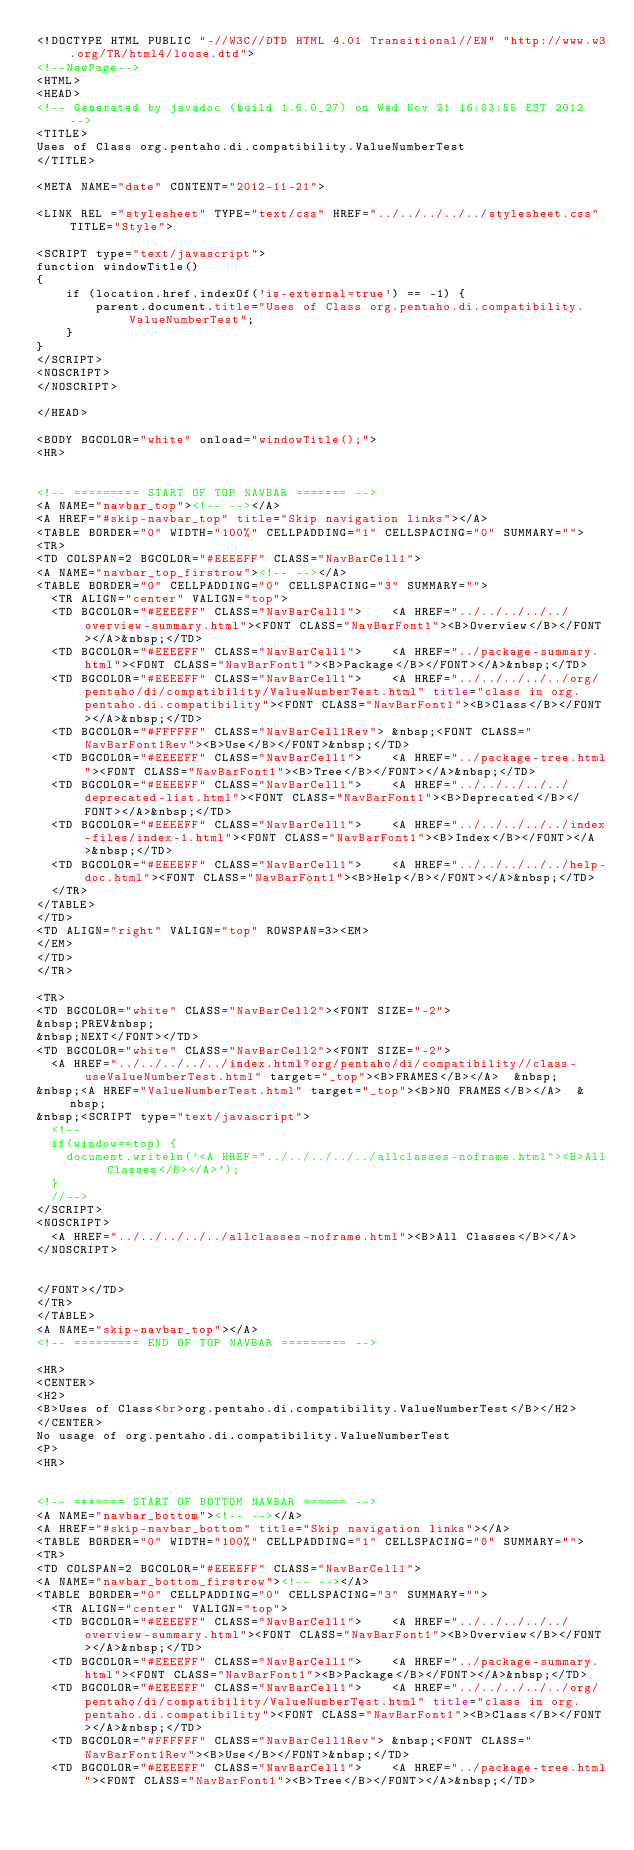Convert code to text. <code><loc_0><loc_0><loc_500><loc_500><_HTML_><!DOCTYPE HTML PUBLIC "-//W3C//DTD HTML 4.01 Transitional//EN" "http://www.w3.org/TR/html4/loose.dtd">
<!--NewPage-->
<HTML>
<HEAD>
<!-- Generated by javadoc (build 1.6.0_27) on Wed Nov 21 16:03:55 EST 2012 -->
<TITLE>
Uses of Class org.pentaho.di.compatibility.ValueNumberTest
</TITLE>

<META NAME="date" CONTENT="2012-11-21">

<LINK REL ="stylesheet" TYPE="text/css" HREF="../../../../../stylesheet.css" TITLE="Style">

<SCRIPT type="text/javascript">
function windowTitle()
{
    if (location.href.indexOf('is-external=true') == -1) {
        parent.document.title="Uses of Class org.pentaho.di.compatibility.ValueNumberTest";
    }
}
</SCRIPT>
<NOSCRIPT>
</NOSCRIPT>

</HEAD>

<BODY BGCOLOR="white" onload="windowTitle();">
<HR>


<!-- ========= START OF TOP NAVBAR ======= -->
<A NAME="navbar_top"><!-- --></A>
<A HREF="#skip-navbar_top" title="Skip navigation links"></A>
<TABLE BORDER="0" WIDTH="100%" CELLPADDING="1" CELLSPACING="0" SUMMARY="">
<TR>
<TD COLSPAN=2 BGCOLOR="#EEEEFF" CLASS="NavBarCell1">
<A NAME="navbar_top_firstrow"><!-- --></A>
<TABLE BORDER="0" CELLPADDING="0" CELLSPACING="3" SUMMARY="">
  <TR ALIGN="center" VALIGN="top">
  <TD BGCOLOR="#EEEEFF" CLASS="NavBarCell1">    <A HREF="../../../../../overview-summary.html"><FONT CLASS="NavBarFont1"><B>Overview</B></FONT></A>&nbsp;</TD>
  <TD BGCOLOR="#EEEEFF" CLASS="NavBarCell1">    <A HREF="../package-summary.html"><FONT CLASS="NavBarFont1"><B>Package</B></FONT></A>&nbsp;</TD>
  <TD BGCOLOR="#EEEEFF" CLASS="NavBarCell1">    <A HREF="../../../../../org/pentaho/di/compatibility/ValueNumberTest.html" title="class in org.pentaho.di.compatibility"><FONT CLASS="NavBarFont1"><B>Class</B></FONT></A>&nbsp;</TD>
  <TD BGCOLOR="#FFFFFF" CLASS="NavBarCell1Rev"> &nbsp;<FONT CLASS="NavBarFont1Rev"><B>Use</B></FONT>&nbsp;</TD>
  <TD BGCOLOR="#EEEEFF" CLASS="NavBarCell1">    <A HREF="../package-tree.html"><FONT CLASS="NavBarFont1"><B>Tree</B></FONT></A>&nbsp;</TD>
  <TD BGCOLOR="#EEEEFF" CLASS="NavBarCell1">    <A HREF="../../../../../deprecated-list.html"><FONT CLASS="NavBarFont1"><B>Deprecated</B></FONT></A>&nbsp;</TD>
  <TD BGCOLOR="#EEEEFF" CLASS="NavBarCell1">    <A HREF="../../../../../index-files/index-1.html"><FONT CLASS="NavBarFont1"><B>Index</B></FONT></A>&nbsp;</TD>
  <TD BGCOLOR="#EEEEFF" CLASS="NavBarCell1">    <A HREF="../../../../../help-doc.html"><FONT CLASS="NavBarFont1"><B>Help</B></FONT></A>&nbsp;</TD>
  </TR>
</TABLE>
</TD>
<TD ALIGN="right" VALIGN="top" ROWSPAN=3><EM>
</EM>
</TD>
</TR>

<TR>
<TD BGCOLOR="white" CLASS="NavBarCell2"><FONT SIZE="-2">
&nbsp;PREV&nbsp;
&nbsp;NEXT</FONT></TD>
<TD BGCOLOR="white" CLASS="NavBarCell2"><FONT SIZE="-2">
  <A HREF="../../../../../index.html?org/pentaho/di/compatibility//class-useValueNumberTest.html" target="_top"><B>FRAMES</B></A>  &nbsp;
&nbsp;<A HREF="ValueNumberTest.html" target="_top"><B>NO FRAMES</B></A>  &nbsp;
&nbsp;<SCRIPT type="text/javascript">
  <!--
  if(window==top) {
    document.writeln('<A HREF="../../../../../allclasses-noframe.html"><B>All Classes</B></A>');
  }
  //-->
</SCRIPT>
<NOSCRIPT>
  <A HREF="../../../../../allclasses-noframe.html"><B>All Classes</B></A>
</NOSCRIPT>


</FONT></TD>
</TR>
</TABLE>
<A NAME="skip-navbar_top"></A>
<!-- ========= END OF TOP NAVBAR ========= -->

<HR>
<CENTER>
<H2>
<B>Uses of Class<br>org.pentaho.di.compatibility.ValueNumberTest</B></H2>
</CENTER>
No usage of org.pentaho.di.compatibility.ValueNumberTest
<P>
<HR>


<!-- ======= START OF BOTTOM NAVBAR ====== -->
<A NAME="navbar_bottom"><!-- --></A>
<A HREF="#skip-navbar_bottom" title="Skip navigation links"></A>
<TABLE BORDER="0" WIDTH="100%" CELLPADDING="1" CELLSPACING="0" SUMMARY="">
<TR>
<TD COLSPAN=2 BGCOLOR="#EEEEFF" CLASS="NavBarCell1">
<A NAME="navbar_bottom_firstrow"><!-- --></A>
<TABLE BORDER="0" CELLPADDING="0" CELLSPACING="3" SUMMARY="">
  <TR ALIGN="center" VALIGN="top">
  <TD BGCOLOR="#EEEEFF" CLASS="NavBarCell1">    <A HREF="../../../../../overview-summary.html"><FONT CLASS="NavBarFont1"><B>Overview</B></FONT></A>&nbsp;</TD>
  <TD BGCOLOR="#EEEEFF" CLASS="NavBarCell1">    <A HREF="../package-summary.html"><FONT CLASS="NavBarFont1"><B>Package</B></FONT></A>&nbsp;</TD>
  <TD BGCOLOR="#EEEEFF" CLASS="NavBarCell1">    <A HREF="../../../../../org/pentaho/di/compatibility/ValueNumberTest.html" title="class in org.pentaho.di.compatibility"><FONT CLASS="NavBarFont1"><B>Class</B></FONT></A>&nbsp;</TD>
  <TD BGCOLOR="#FFFFFF" CLASS="NavBarCell1Rev"> &nbsp;<FONT CLASS="NavBarFont1Rev"><B>Use</B></FONT>&nbsp;</TD>
  <TD BGCOLOR="#EEEEFF" CLASS="NavBarCell1">    <A HREF="../package-tree.html"><FONT CLASS="NavBarFont1"><B>Tree</B></FONT></A>&nbsp;</TD></code> 